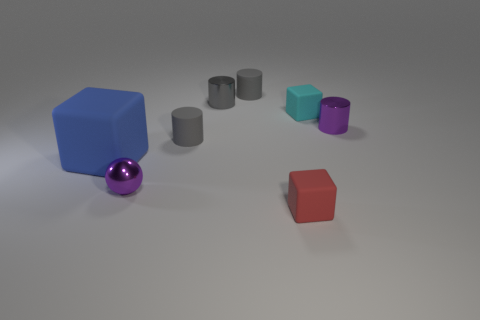Does the sphere have the same color as the big matte cube?
Provide a succinct answer. No. Are the thing in front of the purple sphere and the tiny block that is behind the big object made of the same material?
Your answer should be very brief. Yes. There is a tiny matte cube in front of the big matte block; is it the same color as the big object?
Your response must be concise. No. There is a red rubber thing; how many tiny purple metallic cylinders are behind it?
Make the answer very short. 1. Does the ball have the same material as the tiny gray object in front of the gray shiny cylinder?
Offer a terse response. No. The gray cylinder that is made of the same material as the tiny purple sphere is what size?
Make the answer very short. Small. Is the number of tiny rubber things that are in front of the small purple ball greater than the number of small cubes that are behind the purple cylinder?
Your response must be concise. No. Are there any cyan objects of the same shape as the small gray metal thing?
Keep it short and to the point. No. Is the size of the gray matte cylinder that is behind the purple cylinder the same as the tiny cyan thing?
Keep it short and to the point. Yes. Are any tiny cyan balls visible?
Your answer should be compact. No. 